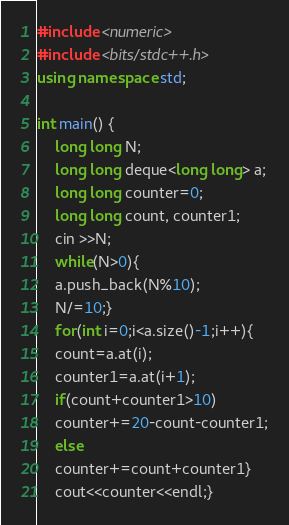<code> <loc_0><loc_0><loc_500><loc_500><_C++_>#include <numeric>
#include <bits/stdc++.h>
using namespace std;

int main() {
    long long N;
    long long deque<long long> a;
    long long counter=0;
    long long count, counter1;
    cin >>N;
    while(N>0){
    a.push_back(N%10);
    N/=10;}
    for(int i=0;i<a.size()-1;i++){
    count=a.at(i);
    counter1=a.at(i+1);
    if(count+counter1>10)
    counter+=20-count-counter1;
    else
    counter+=count+counter1}
    cout<<counter<<endl;}</code> 